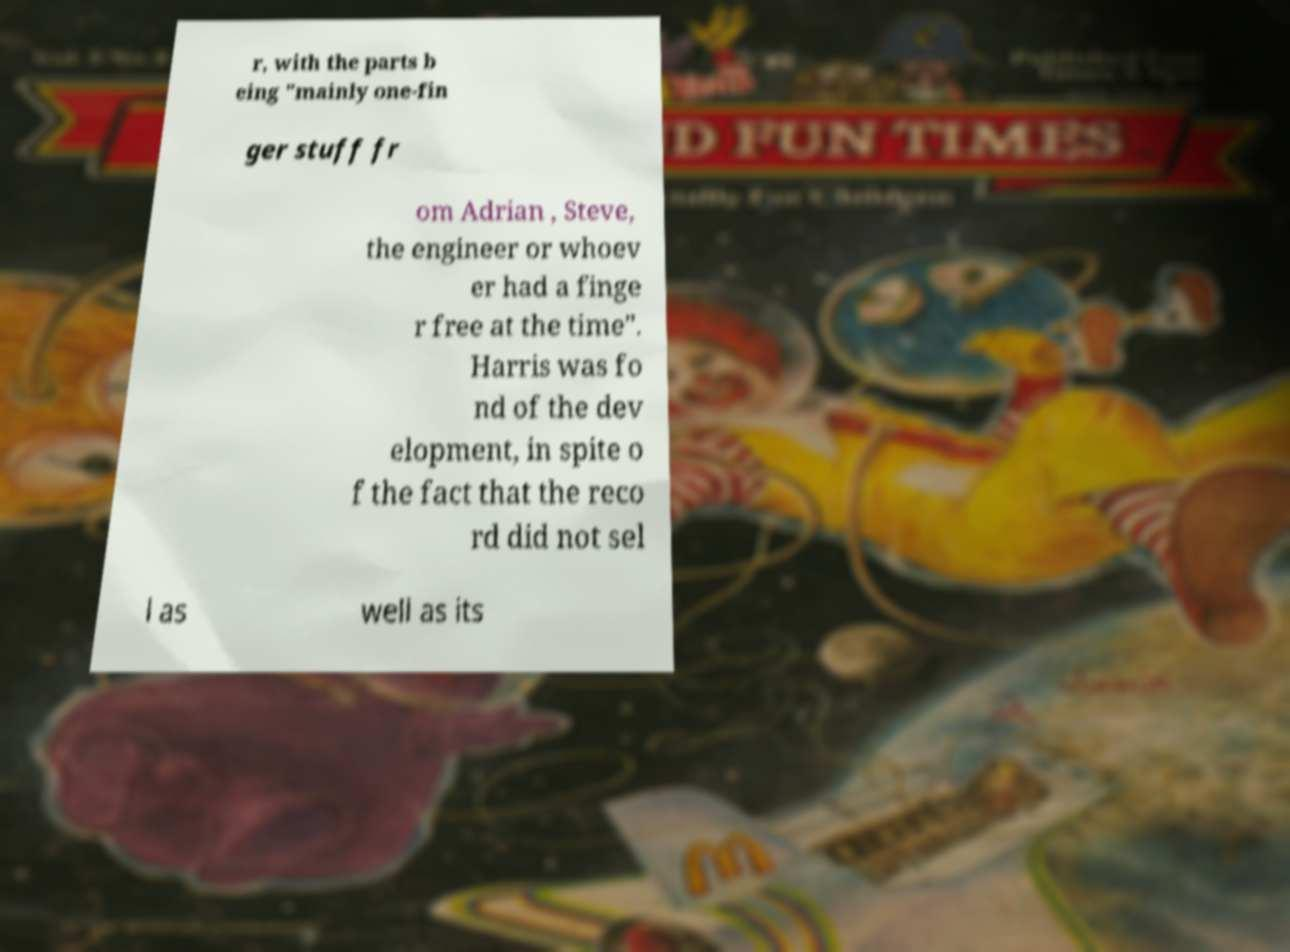Please read and relay the text visible in this image. What does it say? r, with the parts b eing "mainly one-fin ger stuff fr om Adrian , Steve, the engineer or whoev er had a finge r free at the time". Harris was fo nd of the dev elopment, in spite o f the fact that the reco rd did not sel l as well as its 